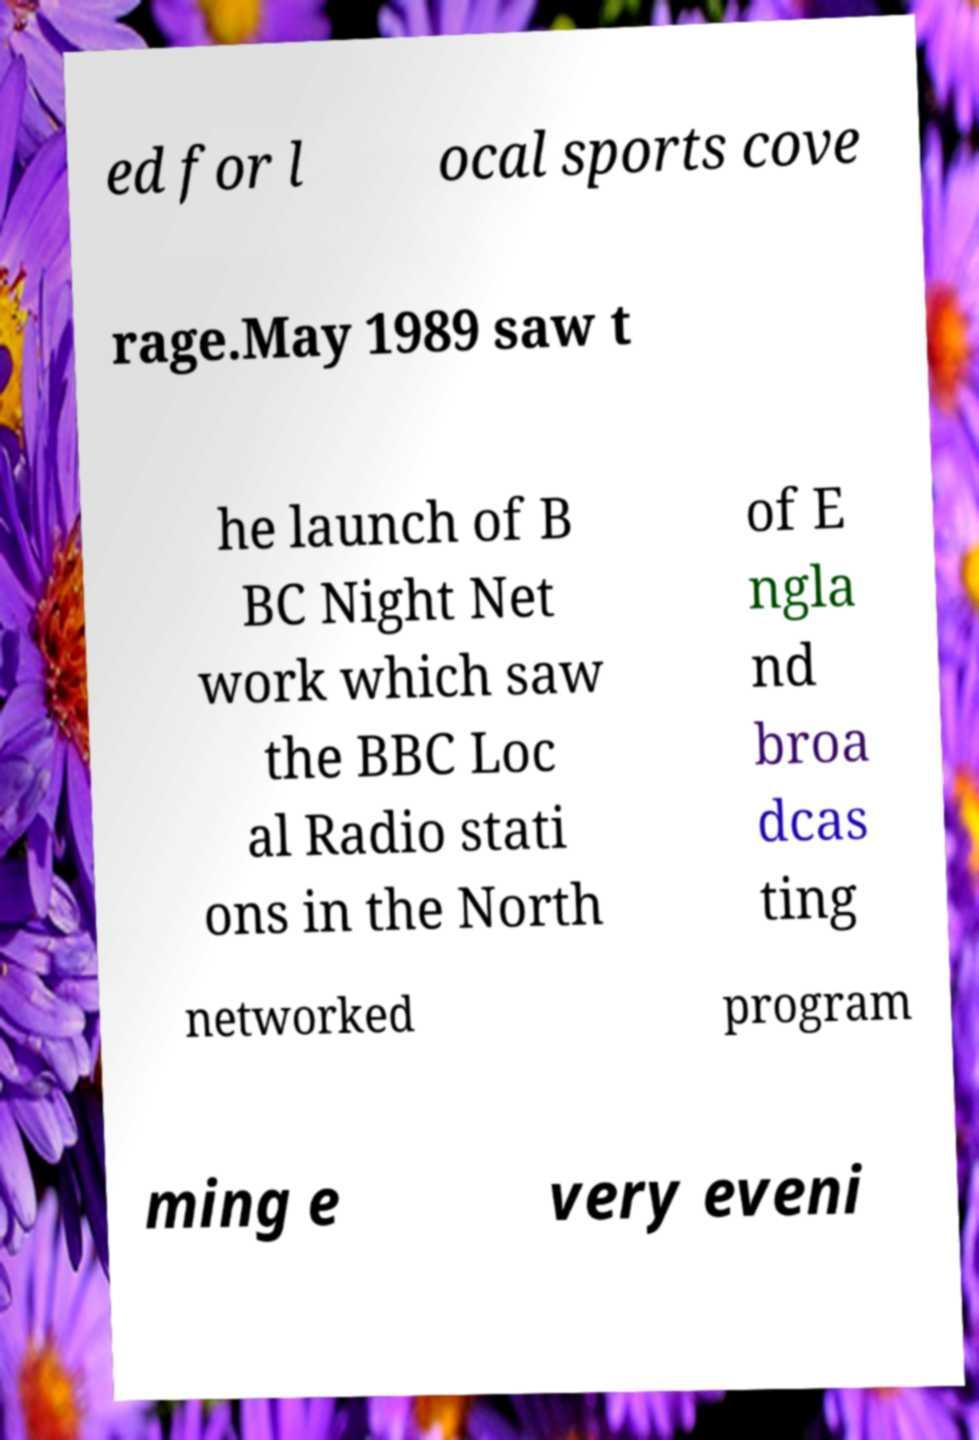Please read and relay the text visible in this image. What does it say? ed for l ocal sports cove rage.May 1989 saw t he launch of B BC Night Net work which saw the BBC Loc al Radio stati ons in the North of E ngla nd broa dcas ting networked program ming e very eveni 